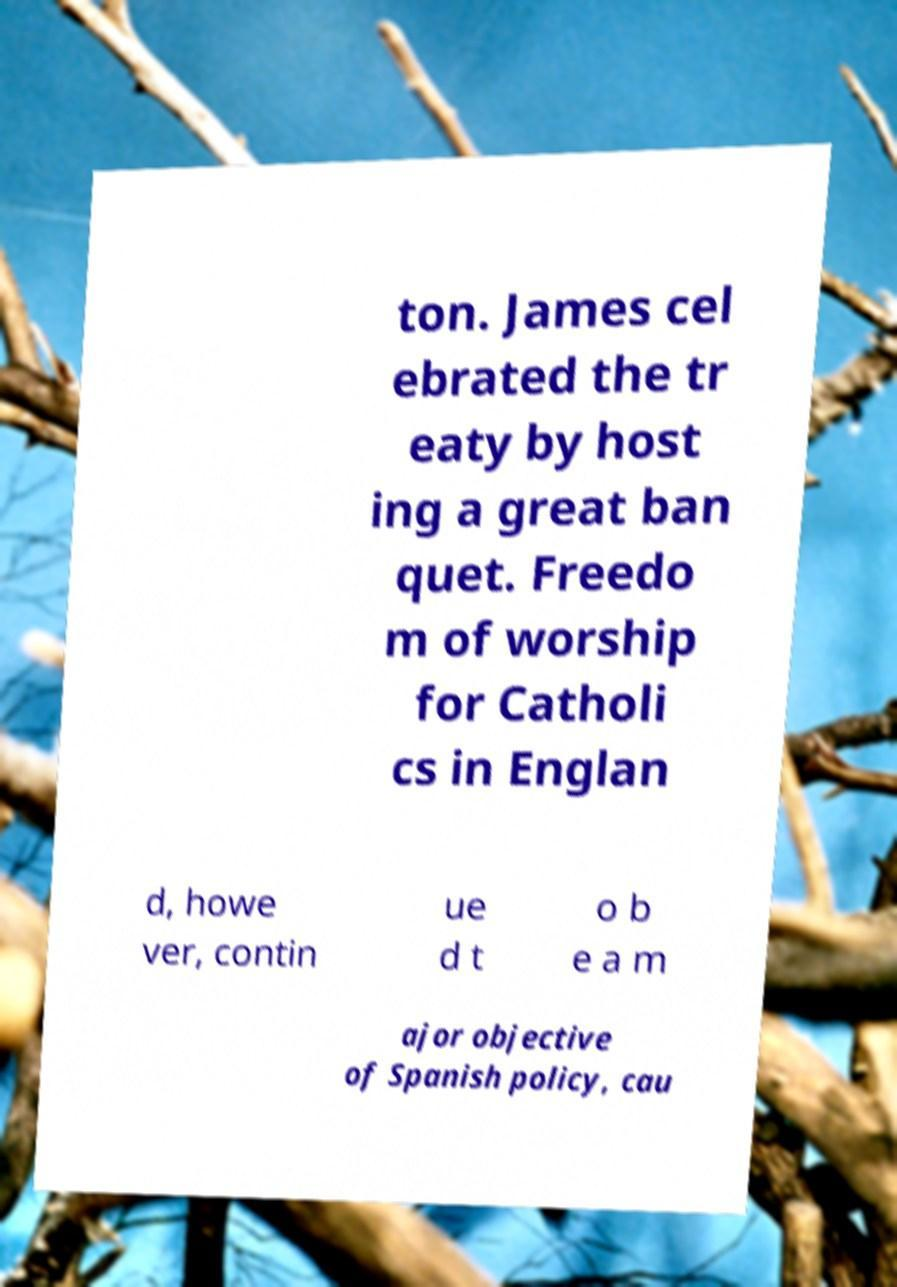Could you extract and type out the text from this image? ton. James cel ebrated the tr eaty by host ing a great ban quet. Freedo m of worship for Catholi cs in Englan d, howe ver, contin ue d t o b e a m ajor objective of Spanish policy, cau 